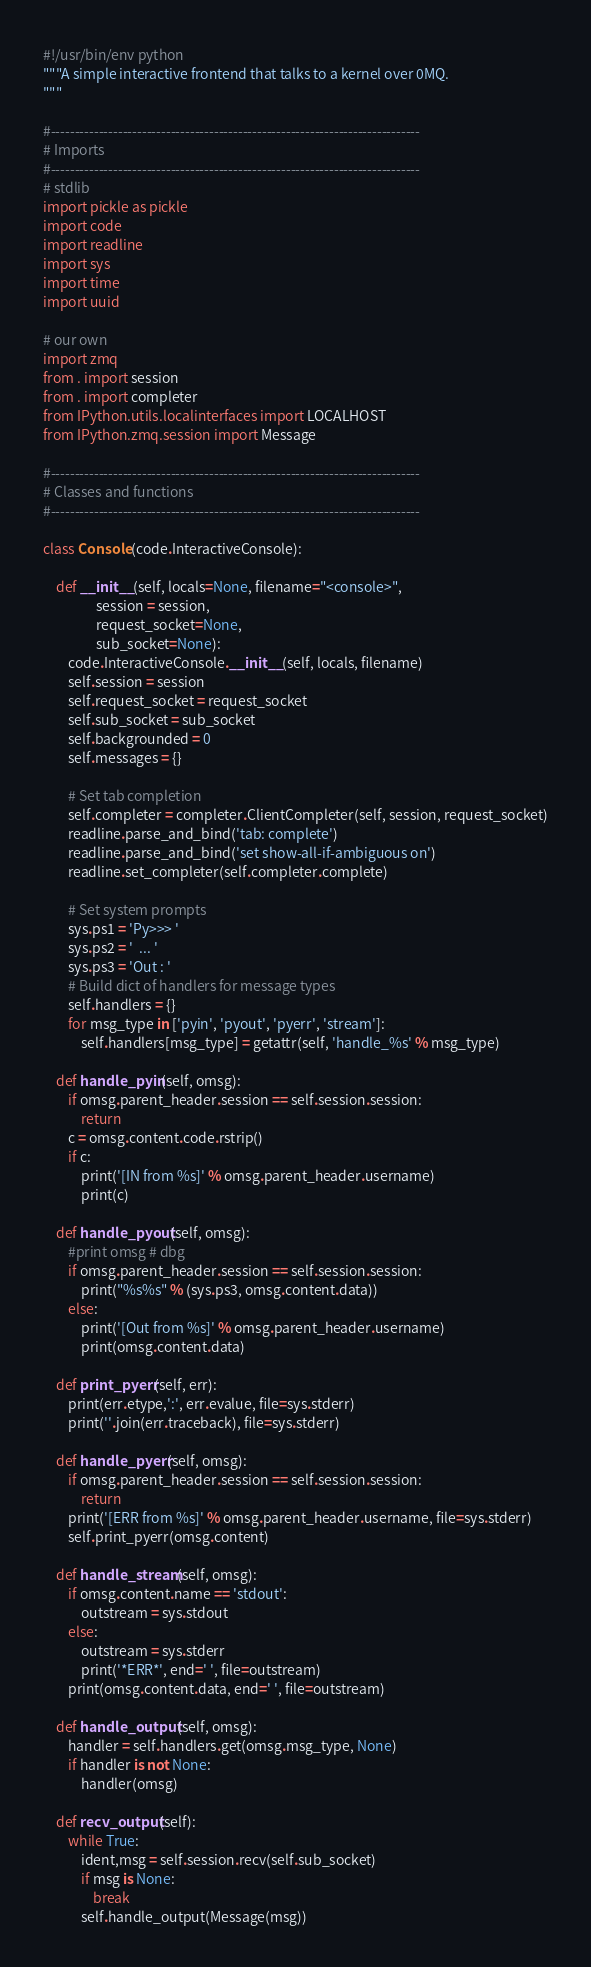Convert code to text. <code><loc_0><loc_0><loc_500><loc_500><_Python_>#!/usr/bin/env python
"""A simple interactive frontend that talks to a kernel over 0MQ.
"""

#-----------------------------------------------------------------------------
# Imports
#-----------------------------------------------------------------------------
# stdlib
import pickle as pickle
import code
import readline
import sys
import time
import uuid

# our own
import zmq
from . import session
from . import completer
from IPython.utils.localinterfaces import LOCALHOST
from IPython.zmq.session import Message

#-----------------------------------------------------------------------------
# Classes and functions
#-----------------------------------------------------------------------------

class Console(code.InteractiveConsole):

    def __init__(self, locals=None, filename="<console>",
                 session = session,
                 request_socket=None,
                 sub_socket=None):
        code.InteractiveConsole.__init__(self, locals, filename)
        self.session = session
        self.request_socket = request_socket
        self.sub_socket = sub_socket
        self.backgrounded = 0
        self.messages = {}

        # Set tab completion
        self.completer = completer.ClientCompleter(self, session, request_socket)
        readline.parse_and_bind('tab: complete')
        readline.parse_and_bind('set show-all-if-ambiguous on')
        readline.set_completer(self.completer.complete)

        # Set system prompts
        sys.ps1 = 'Py>>> '
        sys.ps2 = '  ... '
        sys.ps3 = 'Out : '
        # Build dict of handlers for message types
        self.handlers = {}
        for msg_type in ['pyin', 'pyout', 'pyerr', 'stream']:
            self.handlers[msg_type] = getattr(self, 'handle_%s' % msg_type)

    def handle_pyin(self, omsg):
        if omsg.parent_header.session == self.session.session:
            return
        c = omsg.content.code.rstrip()
        if c:
            print('[IN from %s]' % omsg.parent_header.username)
            print(c)

    def handle_pyout(self, omsg):
        #print omsg # dbg
        if omsg.parent_header.session == self.session.session:
            print("%s%s" % (sys.ps3, omsg.content.data))
        else:
            print('[Out from %s]' % omsg.parent_header.username)
            print(omsg.content.data)

    def print_pyerr(self, err):
        print(err.etype,':', err.evalue, file=sys.stderr)
        print(''.join(err.traceback), file=sys.stderr)

    def handle_pyerr(self, omsg):
        if omsg.parent_header.session == self.session.session:
            return
        print('[ERR from %s]' % omsg.parent_header.username, file=sys.stderr)
        self.print_pyerr(omsg.content)

    def handle_stream(self, omsg):
        if omsg.content.name == 'stdout':
            outstream = sys.stdout
        else:
            outstream = sys.stderr
            print('*ERR*', end=' ', file=outstream)
        print(omsg.content.data, end=' ', file=outstream)

    def handle_output(self, omsg):
        handler = self.handlers.get(omsg.msg_type, None)
        if handler is not None:
            handler(omsg)

    def recv_output(self):
        while True:
            ident,msg = self.session.recv(self.sub_socket)
            if msg is None:
                break
            self.handle_output(Message(msg))
</code> 